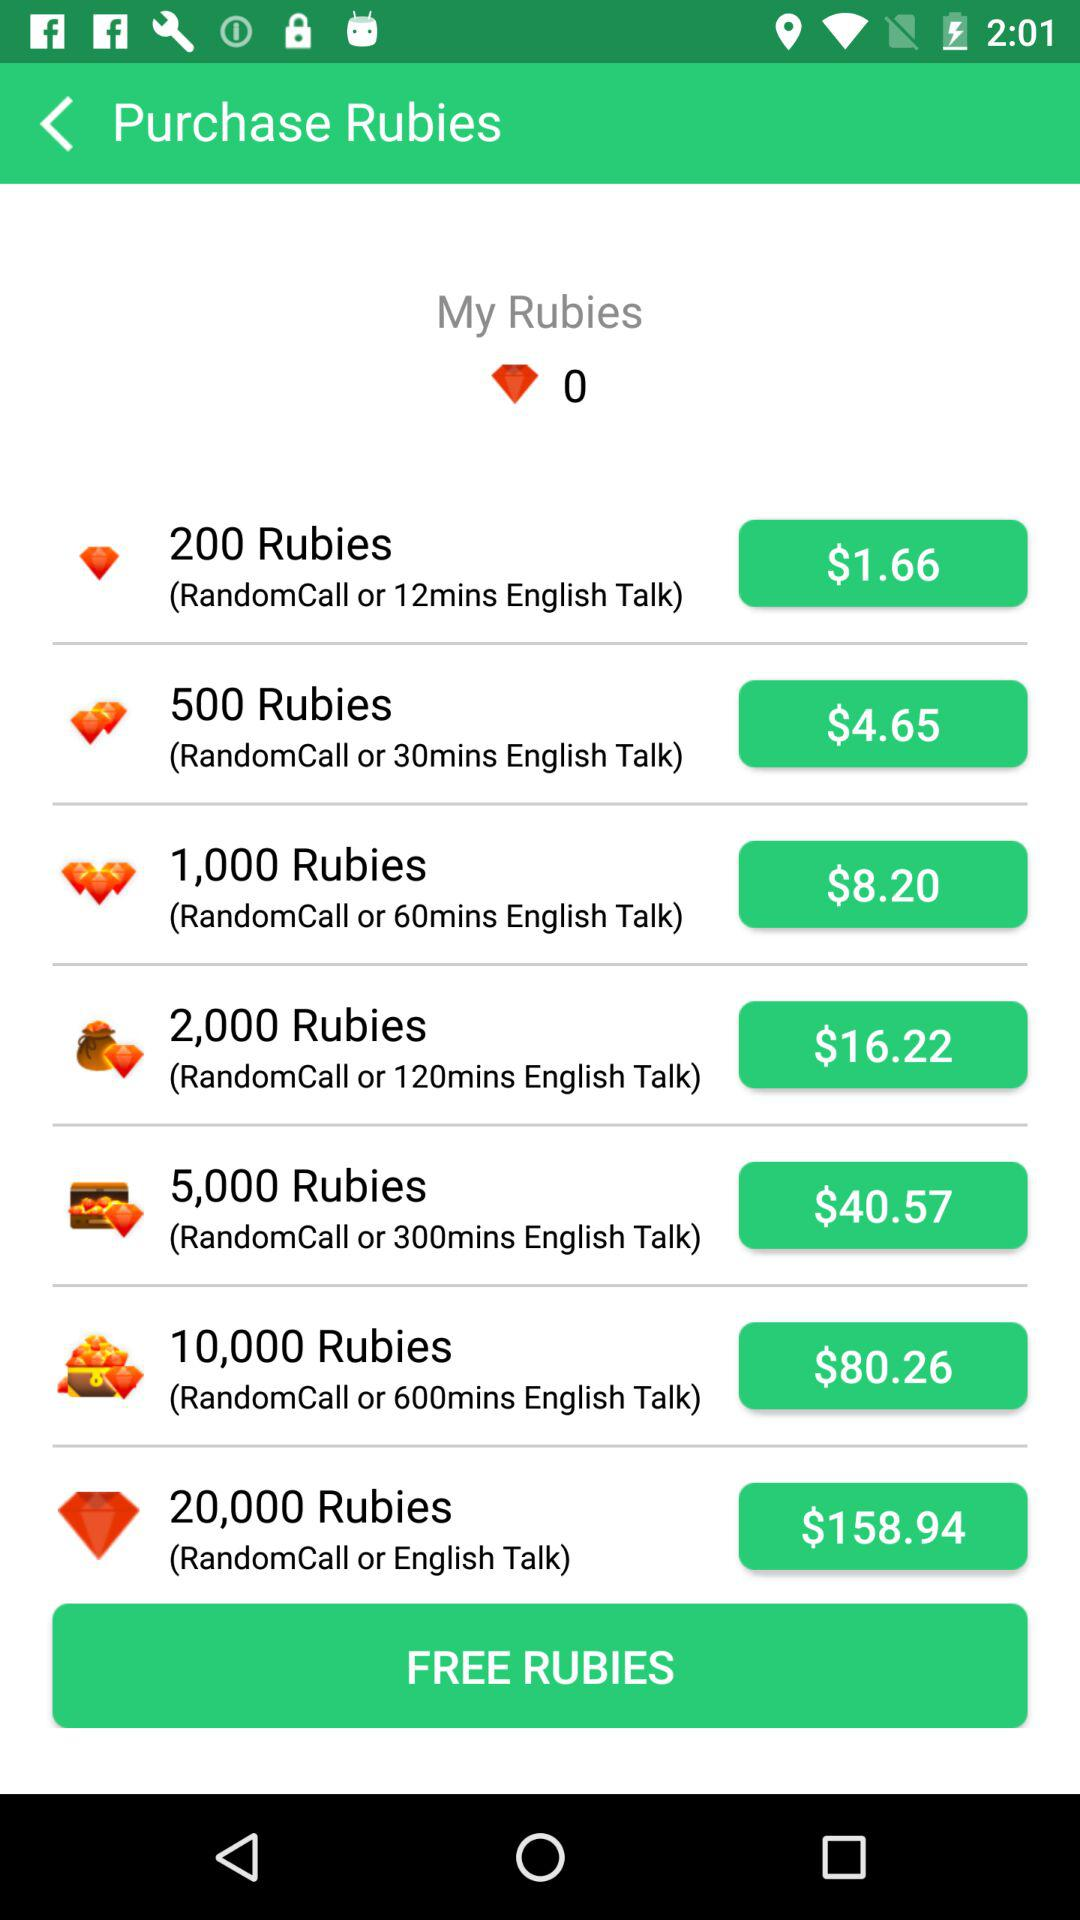How many rubies are available for $4.65?
Answer the question using a single word or phrase. 500 